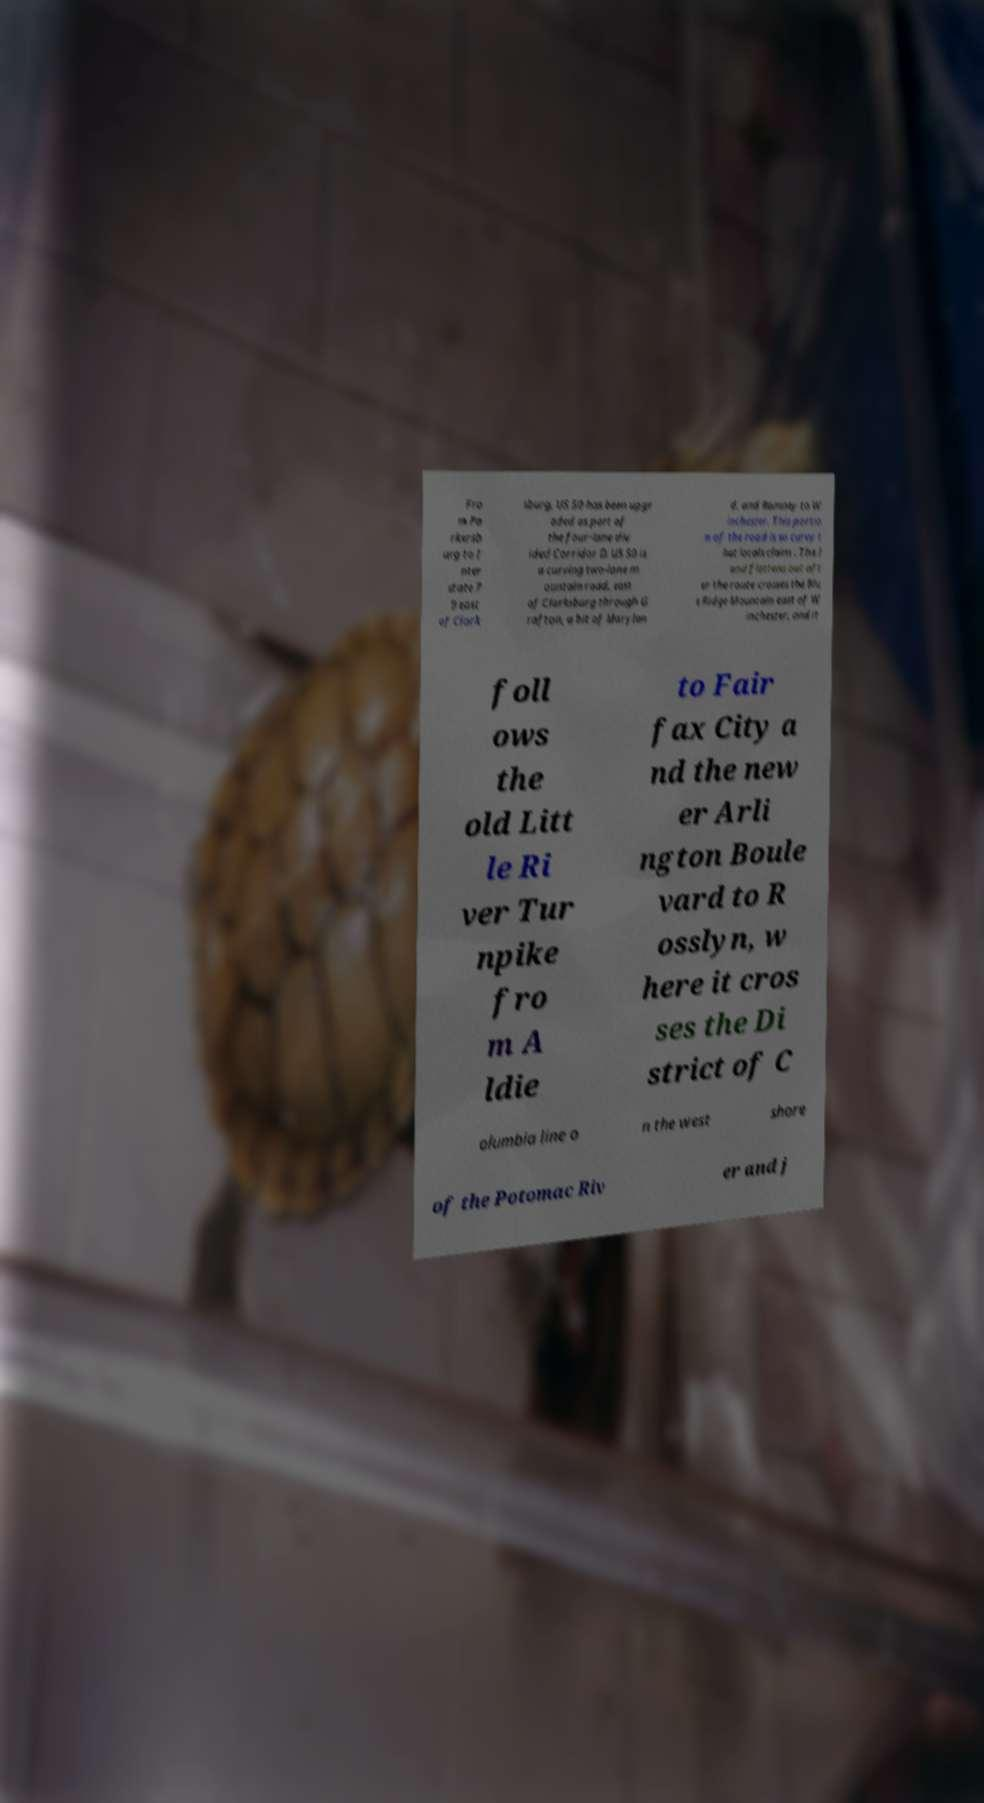There's text embedded in this image that I need extracted. Can you transcribe it verbatim? Fro m Pa rkersb urg to I nter state 7 9 east of Clark sburg, US 50 has been upgr aded as part of the four-lane div ided Corridor D. US 50 is a curving two-lane m ountain road, east of Clarksburg through G rafton, a bit of Marylan d, and Romney to W inchester. This portio n of the road is so curvy t hat locals claim . The l and flattens out aft er the route crosses the Blu e Ridge Mountain east of W inchester, and it foll ows the old Litt le Ri ver Tur npike fro m A ldie to Fair fax City a nd the new er Arli ngton Boule vard to R osslyn, w here it cros ses the Di strict of C olumbia line o n the west shore of the Potomac Riv er and j 